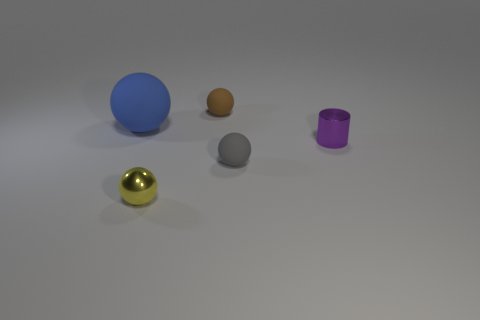How many other objects are there of the same size as the blue object?
Give a very brief answer. 0. Does the tiny metallic sphere have the same color as the small metal cylinder?
Offer a terse response. No. Is the shape of the tiny object to the left of the brown matte ball the same as  the large blue matte thing?
Give a very brief answer. Yes. How many matte objects are both to the right of the big object and behind the metal cylinder?
Provide a succinct answer. 1. What material is the large thing?
Your answer should be compact. Rubber. Is there anything else that is the same color as the small cylinder?
Ensure brevity in your answer.  No. Does the big ball have the same material as the yellow ball?
Your answer should be very brief. No. What number of big rubber spheres are in front of the ball that is to the right of the object that is behind the big blue object?
Your answer should be compact. 0. How many small red rubber cubes are there?
Keep it short and to the point. 0. Are there fewer yellow metallic objects to the right of the small purple cylinder than balls that are behind the large object?
Your answer should be very brief. Yes. 